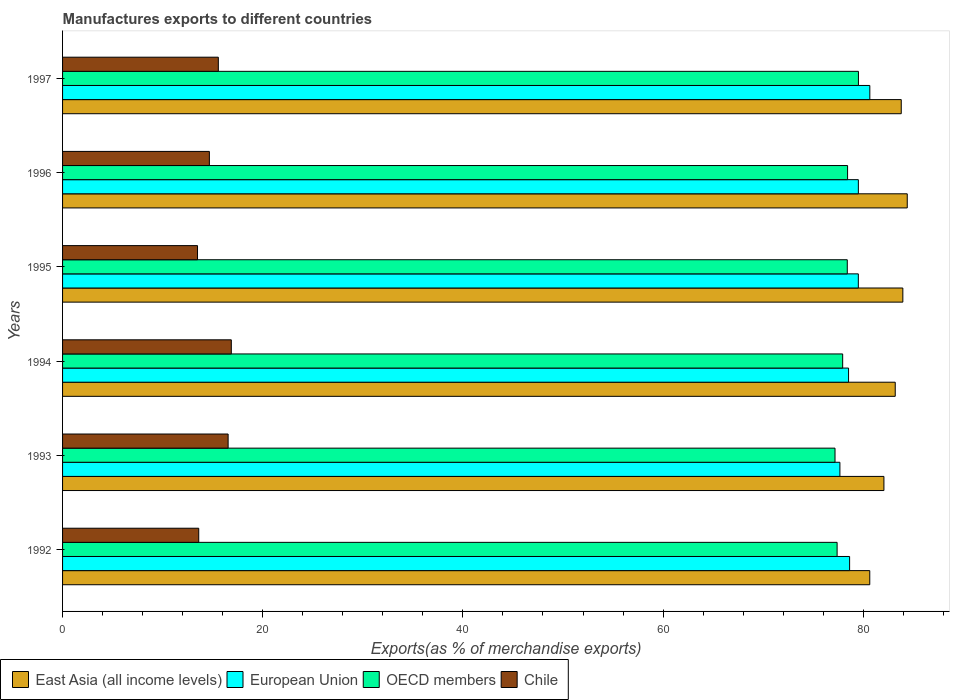How many different coloured bars are there?
Keep it short and to the point. 4. What is the label of the 1st group of bars from the top?
Provide a short and direct response. 1997. In how many cases, is the number of bars for a given year not equal to the number of legend labels?
Make the answer very short. 0. What is the percentage of exports to different countries in European Union in 1994?
Offer a very short reply. 78.53. Across all years, what is the maximum percentage of exports to different countries in Chile?
Your answer should be very brief. 16.86. Across all years, what is the minimum percentage of exports to different countries in OECD members?
Ensure brevity in your answer.  77.18. What is the total percentage of exports to different countries in OECD members in the graph?
Keep it short and to the point. 468.87. What is the difference between the percentage of exports to different countries in Chile in 1992 and that in 1994?
Make the answer very short. -3.25. What is the difference between the percentage of exports to different countries in OECD members in 1994 and the percentage of exports to different countries in East Asia (all income levels) in 1995?
Provide a short and direct response. -6.01. What is the average percentage of exports to different countries in East Asia (all income levels) per year?
Make the answer very short. 83.01. In the year 1994, what is the difference between the percentage of exports to different countries in OECD members and percentage of exports to different countries in European Union?
Make the answer very short. -0.59. In how many years, is the percentage of exports to different countries in Chile greater than 40 %?
Your answer should be compact. 0. What is the ratio of the percentage of exports to different countries in East Asia (all income levels) in 1993 to that in 1996?
Offer a very short reply. 0.97. Is the difference between the percentage of exports to different countries in OECD members in 1995 and 1997 greater than the difference between the percentage of exports to different countries in European Union in 1995 and 1997?
Keep it short and to the point. Yes. What is the difference between the highest and the second highest percentage of exports to different countries in European Union?
Give a very brief answer. 1.15. What is the difference between the highest and the lowest percentage of exports to different countries in OECD members?
Provide a short and direct response. 2.34. In how many years, is the percentage of exports to different countries in East Asia (all income levels) greater than the average percentage of exports to different countries in East Asia (all income levels) taken over all years?
Your response must be concise. 4. Is it the case that in every year, the sum of the percentage of exports to different countries in Chile and percentage of exports to different countries in OECD members is greater than the sum of percentage of exports to different countries in East Asia (all income levels) and percentage of exports to different countries in European Union?
Offer a terse response. No. What does the 4th bar from the top in 1993 represents?
Ensure brevity in your answer.  East Asia (all income levels). Are all the bars in the graph horizontal?
Ensure brevity in your answer.  Yes. How many years are there in the graph?
Offer a terse response. 6. How many legend labels are there?
Give a very brief answer. 4. What is the title of the graph?
Provide a succinct answer. Manufactures exports to different countries. What is the label or title of the X-axis?
Ensure brevity in your answer.  Exports(as % of merchandise exports). What is the label or title of the Y-axis?
Offer a terse response. Years. What is the Exports(as % of merchandise exports) in East Asia (all income levels) in 1992?
Provide a short and direct response. 80.65. What is the Exports(as % of merchandise exports) of European Union in 1992?
Provide a succinct answer. 78.64. What is the Exports(as % of merchandise exports) of OECD members in 1992?
Give a very brief answer. 77.39. What is the Exports(as % of merchandise exports) in Chile in 1992?
Offer a very short reply. 13.61. What is the Exports(as % of merchandise exports) in East Asia (all income levels) in 1993?
Provide a short and direct response. 82.07. What is the Exports(as % of merchandise exports) in European Union in 1993?
Ensure brevity in your answer.  77.67. What is the Exports(as % of merchandise exports) in OECD members in 1993?
Keep it short and to the point. 77.18. What is the Exports(as % of merchandise exports) of Chile in 1993?
Make the answer very short. 16.54. What is the Exports(as % of merchandise exports) in East Asia (all income levels) in 1994?
Your response must be concise. 83.2. What is the Exports(as % of merchandise exports) in European Union in 1994?
Make the answer very short. 78.53. What is the Exports(as % of merchandise exports) in OECD members in 1994?
Give a very brief answer. 77.94. What is the Exports(as % of merchandise exports) in Chile in 1994?
Your answer should be very brief. 16.86. What is the Exports(as % of merchandise exports) in East Asia (all income levels) in 1995?
Ensure brevity in your answer.  83.96. What is the Exports(as % of merchandise exports) in European Union in 1995?
Your answer should be compact. 79.51. What is the Exports(as % of merchandise exports) of OECD members in 1995?
Offer a terse response. 78.4. What is the Exports(as % of merchandise exports) in Chile in 1995?
Ensure brevity in your answer.  13.48. What is the Exports(as % of merchandise exports) of East Asia (all income levels) in 1996?
Your answer should be very brief. 84.4. What is the Exports(as % of merchandise exports) in European Union in 1996?
Make the answer very short. 79.51. What is the Exports(as % of merchandise exports) of OECD members in 1996?
Offer a very short reply. 78.43. What is the Exports(as % of merchandise exports) of Chile in 1996?
Your response must be concise. 14.67. What is the Exports(as % of merchandise exports) of East Asia (all income levels) in 1997?
Make the answer very short. 83.8. What is the Exports(as % of merchandise exports) in European Union in 1997?
Give a very brief answer. 80.66. What is the Exports(as % of merchandise exports) in OECD members in 1997?
Your response must be concise. 79.52. What is the Exports(as % of merchandise exports) in Chile in 1997?
Keep it short and to the point. 15.56. Across all years, what is the maximum Exports(as % of merchandise exports) in East Asia (all income levels)?
Give a very brief answer. 84.4. Across all years, what is the maximum Exports(as % of merchandise exports) of European Union?
Offer a terse response. 80.66. Across all years, what is the maximum Exports(as % of merchandise exports) of OECD members?
Keep it short and to the point. 79.52. Across all years, what is the maximum Exports(as % of merchandise exports) of Chile?
Give a very brief answer. 16.86. Across all years, what is the minimum Exports(as % of merchandise exports) in East Asia (all income levels)?
Your answer should be compact. 80.65. Across all years, what is the minimum Exports(as % of merchandise exports) of European Union?
Keep it short and to the point. 77.67. Across all years, what is the minimum Exports(as % of merchandise exports) of OECD members?
Your answer should be compact. 77.18. Across all years, what is the minimum Exports(as % of merchandise exports) of Chile?
Your answer should be very brief. 13.48. What is the total Exports(as % of merchandise exports) of East Asia (all income levels) in the graph?
Your answer should be very brief. 498.06. What is the total Exports(as % of merchandise exports) in European Union in the graph?
Your answer should be compact. 474.51. What is the total Exports(as % of merchandise exports) of OECD members in the graph?
Make the answer very short. 468.87. What is the total Exports(as % of merchandise exports) of Chile in the graph?
Ensure brevity in your answer.  90.72. What is the difference between the Exports(as % of merchandise exports) of East Asia (all income levels) in 1992 and that in 1993?
Give a very brief answer. -1.42. What is the difference between the Exports(as % of merchandise exports) of European Union in 1992 and that in 1993?
Give a very brief answer. 0.97. What is the difference between the Exports(as % of merchandise exports) of OECD members in 1992 and that in 1993?
Your answer should be very brief. 0.21. What is the difference between the Exports(as % of merchandise exports) in Chile in 1992 and that in 1993?
Ensure brevity in your answer.  -2.94. What is the difference between the Exports(as % of merchandise exports) in East Asia (all income levels) in 1992 and that in 1994?
Offer a very short reply. -2.55. What is the difference between the Exports(as % of merchandise exports) in European Union in 1992 and that in 1994?
Make the answer very short. 0.11. What is the difference between the Exports(as % of merchandise exports) of OECD members in 1992 and that in 1994?
Your response must be concise. -0.56. What is the difference between the Exports(as % of merchandise exports) in Chile in 1992 and that in 1994?
Your response must be concise. -3.25. What is the difference between the Exports(as % of merchandise exports) in East Asia (all income levels) in 1992 and that in 1995?
Your response must be concise. -3.31. What is the difference between the Exports(as % of merchandise exports) in European Union in 1992 and that in 1995?
Give a very brief answer. -0.87. What is the difference between the Exports(as % of merchandise exports) in OECD members in 1992 and that in 1995?
Make the answer very short. -1.02. What is the difference between the Exports(as % of merchandise exports) in Chile in 1992 and that in 1995?
Ensure brevity in your answer.  0.12. What is the difference between the Exports(as % of merchandise exports) in East Asia (all income levels) in 1992 and that in 1996?
Offer a terse response. -3.75. What is the difference between the Exports(as % of merchandise exports) in European Union in 1992 and that in 1996?
Provide a short and direct response. -0.87. What is the difference between the Exports(as % of merchandise exports) in OECD members in 1992 and that in 1996?
Your answer should be very brief. -1.04. What is the difference between the Exports(as % of merchandise exports) of Chile in 1992 and that in 1996?
Provide a short and direct response. -1.06. What is the difference between the Exports(as % of merchandise exports) in East Asia (all income levels) in 1992 and that in 1997?
Ensure brevity in your answer.  -3.15. What is the difference between the Exports(as % of merchandise exports) in European Union in 1992 and that in 1997?
Your answer should be very brief. -2.02. What is the difference between the Exports(as % of merchandise exports) of OECD members in 1992 and that in 1997?
Provide a succinct answer. -2.13. What is the difference between the Exports(as % of merchandise exports) in Chile in 1992 and that in 1997?
Ensure brevity in your answer.  -1.96. What is the difference between the Exports(as % of merchandise exports) of East Asia (all income levels) in 1993 and that in 1994?
Offer a very short reply. -1.13. What is the difference between the Exports(as % of merchandise exports) in European Union in 1993 and that in 1994?
Your answer should be very brief. -0.87. What is the difference between the Exports(as % of merchandise exports) in OECD members in 1993 and that in 1994?
Keep it short and to the point. -0.76. What is the difference between the Exports(as % of merchandise exports) in Chile in 1993 and that in 1994?
Provide a short and direct response. -0.32. What is the difference between the Exports(as % of merchandise exports) of East Asia (all income levels) in 1993 and that in 1995?
Offer a very short reply. -1.89. What is the difference between the Exports(as % of merchandise exports) of European Union in 1993 and that in 1995?
Give a very brief answer. -1.84. What is the difference between the Exports(as % of merchandise exports) of OECD members in 1993 and that in 1995?
Your response must be concise. -1.22. What is the difference between the Exports(as % of merchandise exports) of Chile in 1993 and that in 1995?
Your answer should be compact. 3.06. What is the difference between the Exports(as % of merchandise exports) of East Asia (all income levels) in 1993 and that in 1996?
Give a very brief answer. -2.33. What is the difference between the Exports(as % of merchandise exports) in European Union in 1993 and that in 1996?
Your answer should be very brief. -1.84. What is the difference between the Exports(as % of merchandise exports) of OECD members in 1993 and that in 1996?
Provide a short and direct response. -1.25. What is the difference between the Exports(as % of merchandise exports) of Chile in 1993 and that in 1996?
Your answer should be very brief. 1.87. What is the difference between the Exports(as % of merchandise exports) in East Asia (all income levels) in 1993 and that in 1997?
Your answer should be very brief. -1.73. What is the difference between the Exports(as % of merchandise exports) in European Union in 1993 and that in 1997?
Provide a short and direct response. -2.99. What is the difference between the Exports(as % of merchandise exports) in OECD members in 1993 and that in 1997?
Offer a very short reply. -2.34. What is the difference between the Exports(as % of merchandise exports) of Chile in 1993 and that in 1997?
Make the answer very short. 0.98. What is the difference between the Exports(as % of merchandise exports) of East Asia (all income levels) in 1994 and that in 1995?
Offer a terse response. -0.76. What is the difference between the Exports(as % of merchandise exports) of European Union in 1994 and that in 1995?
Make the answer very short. -0.98. What is the difference between the Exports(as % of merchandise exports) in OECD members in 1994 and that in 1995?
Your answer should be compact. -0.46. What is the difference between the Exports(as % of merchandise exports) in Chile in 1994 and that in 1995?
Make the answer very short. 3.38. What is the difference between the Exports(as % of merchandise exports) in East Asia (all income levels) in 1994 and that in 1996?
Provide a succinct answer. -1.2. What is the difference between the Exports(as % of merchandise exports) of European Union in 1994 and that in 1996?
Your response must be concise. -0.98. What is the difference between the Exports(as % of merchandise exports) in OECD members in 1994 and that in 1996?
Your response must be concise. -0.49. What is the difference between the Exports(as % of merchandise exports) of Chile in 1994 and that in 1996?
Ensure brevity in your answer.  2.19. What is the difference between the Exports(as % of merchandise exports) of East Asia (all income levels) in 1994 and that in 1997?
Give a very brief answer. -0.6. What is the difference between the Exports(as % of merchandise exports) in European Union in 1994 and that in 1997?
Provide a succinct answer. -2.12. What is the difference between the Exports(as % of merchandise exports) of OECD members in 1994 and that in 1997?
Your answer should be compact. -1.58. What is the difference between the Exports(as % of merchandise exports) in Chile in 1994 and that in 1997?
Provide a succinct answer. 1.3. What is the difference between the Exports(as % of merchandise exports) in East Asia (all income levels) in 1995 and that in 1996?
Keep it short and to the point. -0.44. What is the difference between the Exports(as % of merchandise exports) of European Union in 1995 and that in 1996?
Ensure brevity in your answer.  -0. What is the difference between the Exports(as % of merchandise exports) in OECD members in 1995 and that in 1996?
Give a very brief answer. -0.03. What is the difference between the Exports(as % of merchandise exports) of Chile in 1995 and that in 1996?
Your answer should be very brief. -1.19. What is the difference between the Exports(as % of merchandise exports) in East Asia (all income levels) in 1995 and that in 1997?
Provide a succinct answer. 0.16. What is the difference between the Exports(as % of merchandise exports) of European Union in 1995 and that in 1997?
Ensure brevity in your answer.  -1.15. What is the difference between the Exports(as % of merchandise exports) in OECD members in 1995 and that in 1997?
Your answer should be very brief. -1.12. What is the difference between the Exports(as % of merchandise exports) of Chile in 1995 and that in 1997?
Your answer should be compact. -2.08. What is the difference between the Exports(as % of merchandise exports) in East Asia (all income levels) in 1996 and that in 1997?
Keep it short and to the point. 0.6. What is the difference between the Exports(as % of merchandise exports) of European Union in 1996 and that in 1997?
Provide a short and direct response. -1.15. What is the difference between the Exports(as % of merchandise exports) of OECD members in 1996 and that in 1997?
Keep it short and to the point. -1.09. What is the difference between the Exports(as % of merchandise exports) in Chile in 1996 and that in 1997?
Keep it short and to the point. -0.89. What is the difference between the Exports(as % of merchandise exports) of East Asia (all income levels) in 1992 and the Exports(as % of merchandise exports) of European Union in 1993?
Your answer should be compact. 2.98. What is the difference between the Exports(as % of merchandise exports) of East Asia (all income levels) in 1992 and the Exports(as % of merchandise exports) of OECD members in 1993?
Offer a terse response. 3.47. What is the difference between the Exports(as % of merchandise exports) of East Asia (all income levels) in 1992 and the Exports(as % of merchandise exports) of Chile in 1993?
Give a very brief answer. 64.11. What is the difference between the Exports(as % of merchandise exports) of European Union in 1992 and the Exports(as % of merchandise exports) of OECD members in 1993?
Make the answer very short. 1.46. What is the difference between the Exports(as % of merchandise exports) of European Union in 1992 and the Exports(as % of merchandise exports) of Chile in 1993?
Your answer should be compact. 62.1. What is the difference between the Exports(as % of merchandise exports) of OECD members in 1992 and the Exports(as % of merchandise exports) of Chile in 1993?
Make the answer very short. 60.85. What is the difference between the Exports(as % of merchandise exports) of East Asia (all income levels) in 1992 and the Exports(as % of merchandise exports) of European Union in 1994?
Keep it short and to the point. 2.12. What is the difference between the Exports(as % of merchandise exports) of East Asia (all income levels) in 1992 and the Exports(as % of merchandise exports) of OECD members in 1994?
Ensure brevity in your answer.  2.71. What is the difference between the Exports(as % of merchandise exports) of East Asia (all income levels) in 1992 and the Exports(as % of merchandise exports) of Chile in 1994?
Your answer should be very brief. 63.79. What is the difference between the Exports(as % of merchandise exports) of European Union in 1992 and the Exports(as % of merchandise exports) of OECD members in 1994?
Keep it short and to the point. 0.69. What is the difference between the Exports(as % of merchandise exports) in European Union in 1992 and the Exports(as % of merchandise exports) in Chile in 1994?
Your answer should be compact. 61.78. What is the difference between the Exports(as % of merchandise exports) of OECD members in 1992 and the Exports(as % of merchandise exports) of Chile in 1994?
Your response must be concise. 60.53. What is the difference between the Exports(as % of merchandise exports) in East Asia (all income levels) in 1992 and the Exports(as % of merchandise exports) in European Union in 1995?
Make the answer very short. 1.14. What is the difference between the Exports(as % of merchandise exports) in East Asia (all income levels) in 1992 and the Exports(as % of merchandise exports) in OECD members in 1995?
Your answer should be very brief. 2.25. What is the difference between the Exports(as % of merchandise exports) in East Asia (all income levels) in 1992 and the Exports(as % of merchandise exports) in Chile in 1995?
Offer a terse response. 67.17. What is the difference between the Exports(as % of merchandise exports) in European Union in 1992 and the Exports(as % of merchandise exports) in OECD members in 1995?
Offer a terse response. 0.23. What is the difference between the Exports(as % of merchandise exports) of European Union in 1992 and the Exports(as % of merchandise exports) of Chile in 1995?
Provide a short and direct response. 65.15. What is the difference between the Exports(as % of merchandise exports) of OECD members in 1992 and the Exports(as % of merchandise exports) of Chile in 1995?
Keep it short and to the point. 63.91. What is the difference between the Exports(as % of merchandise exports) in East Asia (all income levels) in 1992 and the Exports(as % of merchandise exports) in European Union in 1996?
Your answer should be very brief. 1.14. What is the difference between the Exports(as % of merchandise exports) of East Asia (all income levels) in 1992 and the Exports(as % of merchandise exports) of OECD members in 1996?
Offer a terse response. 2.22. What is the difference between the Exports(as % of merchandise exports) in East Asia (all income levels) in 1992 and the Exports(as % of merchandise exports) in Chile in 1996?
Provide a short and direct response. 65.98. What is the difference between the Exports(as % of merchandise exports) of European Union in 1992 and the Exports(as % of merchandise exports) of OECD members in 1996?
Your response must be concise. 0.2. What is the difference between the Exports(as % of merchandise exports) in European Union in 1992 and the Exports(as % of merchandise exports) in Chile in 1996?
Provide a short and direct response. 63.97. What is the difference between the Exports(as % of merchandise exports) in OECD members in 1992 and the Exports(as % of merchandise exports) in Chile in 1996?
Ensure brevity in your answer.  62.72. What is the difference between the Exports(as % of merchandise exports) in East Asia (all income levels) in 1992 and the Exports(as % of merchandise exports) in European Union in 1997?
Give a very brief answer. -0.01. What is the difference between the Exports(as % of merchandise exports) in East Asia (all income levels) in 1992 and the Exports(as % of merchandise exports) in OECD members in 1997?
Keep it short and to the point. 1.13. What is the difference between the Exports(as % of merchandise exports) in East Asia (all income levels) in 1992 and the Exports(as % of merchandise exports) in Chile in 1997?
Provide a succinct answer. 65.09. What is the difference between the Exports(as % of merchandise exports) in European Union in 1992 and the Exports(as % of merchandise exports) in OECD members in 1997?
Your response must be concise. -0.88. What is the difference between the Exports(as % of merchandise exports) in European Union in 1992 and the Exports(as % of merchandise exports) in Chile in 1997?
Keep it short and to the point. 63.07. What is the difference between the Exports(as % of merchandise exports) in OECD members in 1992 and the Exports(as % of merchandise exports) in Chile in 1997?
Ensure brevity in your answer.  61.83. What is the difference between the Exports(as % of merchandise exports) in East Asia (all income levels) in 1993 and the Exports(as % of merchandise exports) in European Union in 1994?
Provide a short and direct response. 3.53. What is the difference between the Exports(as % of merchandise exports) in East Asia (all income levels) in 1993 and the Exports(as % of merchandise exports) in OECD members in 1994?
Your answer should be compact. 4.12. What is the difference between the Exports(as % of merchandise exports) in East Asia (all income levels) in 1993 and the Exports(as % of merchandise exports) in Chile in 1994?
Offer a very short reply. 65.21. What is the difference between the Exports(as % of merchandise exports) of European Union in 1993 and the Exports(as % of merchandise exports) of OECD members in 1994?
Offer a very short reply. -0.28. What is the difference between the Exports(as % of merchandise exports) of European Union in 1993 and the Exports(as % of merchandise exports) of Chile in 1994?
Provide a succinct answer. 60.81. What is the difference between the Exports(as % of merchandise exports) in OECD members in 1993 and the Exports(as % of merchandise exports) in Chile in 1994?
Make the answer very short. 60.32. What is the difference between the Exports(as % of merchandise exports) of East Asia (all income levels) in 1993 and the Exports(as % of merchandise exports) of European Union in 1995?
Provide a succinct answer. 2.56. What is the difference between the Exports(as % of merchandise exports) of East Asia (all income levels) in 1993 and the Exports(as % of merchandise exports) of OECD members in 1995?
Provide a short and direct response. 3.66. What is the difference between the Exports(as % of merchandise exports) of East Asia (all income levels) in 1993 and the Exports(as % of merchandise exports) of Chile in 1995?
Your answer should be compact. 68.58. What is the difference between the Exports(as % of merchandise exports) in European Union in 1993 and the Exports(as % of merchandise exports) in OECD members in 1995?
Provide a short and direct response. -0.74. What is the difference between the Exports(as % of merchandise exports) of European Union in 1993 and the Exports(as % of merchandise exports) of Chile in 1995?
Make the answer very short. 64.18. What is the difference between the Exports(as % of merchandise exports) of OECD members in 1993 and the Exports(as % of merchandise exports) of Chile in 1995?
Your response must be concise. 63.7. What is the difference between the Exports(as % of merchandise exports) in East Asia (all income levels) in 1993 and the Exports(as % of merchandise exports) in European Union in 1996?
Provide a succinct answer. 2.55. What is the difference between the Exports(as % of merchandise exports) in East Asia (all income levels) in 1993 and the Exports(as % of merchandise exports) in OECD members in 1996?
Make the answer very short. 3.63. What is the difference between the Exports(as % of merchandise exports) of East Asia (all income levels) in 1993 and the Exports(as % of merchandise exports) of Chile in 1996?
Offer a very short reply. 67.4. What is the difference between the Exports(as % of merchandise exports) of European Union in 1993 and the Exports(as % of merchandise exports) of OECD members in 1996?
Offer a terse response. -0.77. What is the difference between the Exports(as % of merchandise exports) in European Union in 1993 and the Exports(as % of merchandise exports) in Chile in 1996?
Give a very brief answer. 63. What is the difference between the Exports(as % of merchandise exports) in OECD members in 1993 and the Exports(as % of merchandise exports) in Chile in 1996?
Give a very brief answer. 62.51. What is the difference between the Exports(as % of merchandise exports) of East Asia (all income levels) in 1993 and the Exports(as % of merchandise exports) of European Union in 1997?
Offer a very short reply. 1.41. What is the difference between the Exports(as % of merchandise exports) in East Asia (all income levels) in 1993 and the Exports(as % of merchandise exports) in OECD members in 1997?
Make the answer very short. 2.55. What is the difference between the Exports(as % of merchandise exports) of East Asia (all income levels) in 1993 and the Exports(as % of merchandise exports) of Chile in 1997?
Offer a very short reply. 66.5. What is the difference between the Exports(as % of merchandise exports) of European Union in 1993 and the Exports(as % of merchandise exports) of OECD members in 1997?
Your response must be concise. -1.85. What is the difference between the Exports(as % of merchandise exports) in European Union in 1993 and the Exports(as % of merchandise exports) in Chile in 1997?
Offer a very short reply. 62.1. What is the difference between the Exports(as % of merchandise exports) in OECD members in 1993 and the Exports(as % of merchandise exports) in Chile in 1997?
Offer a very short reply. 61.62. What is the difference between the Exports(as % of merchandise exports) in East Asia (all income levels) in 1994 and the Exports(as % of merchandise exports) in European Union in 1995?
Give a very brief answer. 3.69. What is the difference between the Exports(as % of merchandise exports) of East Asia (all income levels) in 1994 and the Exports(as % of merchandise exports) of OECD members in 1995?
Make the answer very short. 4.79. What is the difference between the Exports(as % of merchandise exports) of East Asia (all income levels) in 1994 and the Exports(as % of merchandise exports) of Chile in 1995?
Your answer should be very brief. 69.71. What is the difference between the Exports(as % of merchandise exports) in European Union in 1994 and the Exports(as % of merchandise exports) in OECD members in 1995?
Offer a terse response. 0.13. What is the difference between the Exports(as % of merchandise exports) in European Union in 1994 and the Exports(as % of merchandise exports) in Chile in 1995?
Your response must be concise. 65.05. What is the difference between the Exports(as % of merchandise exports) of OECD members in 1994 and the Exports(as % of merchandise exports) of Chile in 1995?
Ensure brevity in your answer.  64.46. What is the difference between the Exports(as % of merchandise exports) in East Asia (all income levels) in 1994 and the Exports(as % of merchandise exports) in European Union in 1996?
Give a very brief answer. 3.68. What is the difference between the Exports(as % of merchandise exports) of East Asia (all income levels) in 1994 and the Exports(as % of merchandise exports) of OECD members in 1996?
Keep it short and to the point. 4.76. What is the difference between the Exports(as % of merchandise exports) in East Asia (all income levels) in 1994 and the Exports(as % of merchandise exports) in Chile in 1996?
Provide a short and direct response. 68.53. What is the difference between the Exports(as % of merchandise exports) of European Union in 1994 and the Exports(as % of merchandise exports) of OECD members in 1996?
Your response must be concise. 0.1. What is the difference between the Exports(as % of merchandise exports) of European Union in 1994 and the Exports(as % of merchandise exports) of Chile in 1996?
Your answer should be very brief. 63.86. What is the difference between the Exports(as % of merchandise exports) in OECD members in 1994 and the Exports(as % of merchandise exports) in Chile in 1996?
Make the answer very short. 63.28. What is the difference between the Exports(as % of merchandise exports) of East Asia (all income levels) in 1994 and the Exports(as % of merchandise exports) of European Union in 1997?
Ensure brevity in your answer.  2.54. What is the difference between the Exports(as % of merchandise exports) in East Asia (all income levels) in 1994 and the Exports(as % of merchandise exports) in OECD members in 1997?
Provide a succinct answer. 3.68. What is the difference between the Exports(as % of merchandise exports) in East Asia (all income levels) in 1994 and the Exports(as % of merchandise exports) in Chile in 1997?
Make the answer very short. 67.63. What is the difference between the Exports(as % of merchandise exports) of European Union in 1994 and the Exports(as % of merchandise exports) of OECD members in 1997?
Give a very brief answer. -0.99. What is the difference between the Exports(as % of merchandise exports) in European Union in 1994 and the Exports(as % of merchandise exports) in Chile in 1997?
Offer a very short reply. 62.97. What is the difference between the Exports(as % of merchandise exports) in OECD members in 1994 and the Exports(as % of merchandise exports) in Chile in 1997?
Offer a terse response. 62.38. What is the difference between the Exports(as % of merchandise exports) in East Asia (all income levels) in 1995 and the Exports(as % of merchandise exports) in European Union in 1996?
Give a very brief answer. 4.44. What is the difference between the Exports(as % of merchandise exports) in East Asia (all income levels) in 1995 and the Exports(as % of merchandise exports) in OECD members in 1996?
Provide a succinct answer. 5.52. What is the difference between the Exports(as % of merchandise exports) in East Asia (all income levels) in 1995 and the Exports(as % of merchandise exports) in Chile in 1996?
Keep it short and to the point. 69.29. What is the difference between the Exports(as % of merchandise exports) of European Union in 1995 and the Exports(as % of merchandise exports) of OECD members in 1996?
Offer a very short reply. 1.08. What is the difference between the Exports(as % of merchandise exports) of European Union in 1995 and the Exports(as % of merchandise exports) of Chile in 1996?
Offer a terse response. 64.84. What is the difference between the Exports(as % of merchandise exports) in OECD members in 1995 and the Exports(as % of merchandise exports) in Chile in 1996?
Make the answer very short. 63.74. What is the difference between the Exports(as % of merchandise exports) of East Asia (all income levels) in 1995 and the Exports(as % of merchandise exports) of European Union in 1997?
Your response must be concise. 3.3. What is the difference between the Exports(as % of merchandise exports) in East Asia (all income levels) in 1995 and the Exports(as % of merchandise exports) in OECD members in 1997?
Provide a succinct answer. 4.44. What is the difference between the Exports(as % of merchandise exports) in East Asia (all income levels) in 1995 and the Exports(as % of merchandise exports) in Chile in 1997?
Provide a succinct answer. 68.39. What is the difference between the Exports(as % of merchandise exports) in European Union in 1995 and the Exports(as % of merchandise exports) in OECD members in 1997?
Offer a terse response. -0.01. What is the difference between the Exports(as % of merchandise exports) of European Union in 1995 and the Exports(as % of merchandise exports) of Chile in 1997?
Make the answer very short. 63.95. What is the difference between the Exports(as % of merchandise exports) in OECD members in 1995 and the Exports(as % of merchandise exports) in Chile in 1997?
Give a very brief answer. 62.84. What is the difference between the Exports(as % of merchandise exports) of East Asia (all income levels) in 1996 and the Exports(as % of merchandise exports) of European Union in 1997?
Keep it short and to the point. 3.74. What is the difference between the Exports(as % of merchandise exports) in East Asia (all income levels) in 1996 and the Exports(as % of merchandise exports) in OECD members in 1997?
Keep it short and to the point. 4.88. What is the difference between the Exports(as % of merchandise exports) in East Asia (all income levels) in 1996 and the Exports(as % of merchandise exports) in Chile in 1997?
Give a very brief answer. 68.83. What is the difference between the Exports(as % of merchandise exports) of European Union in 1996 and the Exports(as % of merchandise exports) of OECD members in 1997?
Make the answer very short. -0.01. What is the difference between the Exports(as % of merchandise exports) in European Union in 1996 and the Exports(as % of merchandise exports) in Chile in 1997?
Make the answer very short. 63.95. What is the difference between the Exports(as % of merchandise exports) in OECD members in 1996 and the Exports(as % of merchandise exports) in Chile in 1997?
Keep it short and to the point. 62.87. What is the average Exports(as % of merchandise exports) of East Asia (all income levels) per year?
Offer a terse response. 83.01. What is the average Exports(as % of merchandise exports) in European Union per year?
Provide a short and direct response. 79.09. What is the average Exports(as % of merchandise exports) in OECD members per year?
Keep it short and to the point. 78.14. What is the average Exports(as % of merchandise exports) in Chile per year?
Provide a short and direct response. 15.12. In the year 1992, what is the difference between the Exports(as % of merchandise exports) of East Asia (all income levels) and Exports(as % of merchandise exports) of European Union?
Your answer should be very brief. 2.01. In the year 1992, what is the difference between the Exports(as % of merchandise exports) in East Asia (all income levels) and Exports(as % of merchandise exports) in OECD members?
Provide a succinct answer. 3.26. In the year 1992, what is the difference between the Exports(as % of merchandise exports) of East Asia (all income levels) and Exports(as % of merchandise exports) of Chile?
Your answer should be compact. 67.04. In the year 1992, what is the difference between the Exports(as % of merchandise exports) in European Union and Exports(as % of merchandise exports) in OECD members?
Your answer should be very brief. 1.25. In the year 1992, what is the difference between the Exports(as % of merchandise exports) in European Union and Exports(as % of merchandise exports) in Chile?
Your answer should be very brief. 65.03. In the year 1992, what is the difference between the Exports(as % of merchandise exports) in OECD members and Exports(as % of merchandise exports) in Chile?
Ensure brevity in your answer.  63.78. In the year 1993, what is the difference between the Exports(as % of merchandise exports) in East Asia (all income levels) and Exports(as % of merchandise exports) in European Union?
Keep it short and to the point. 4.4. In the year 1993, what is the difference between the Exports(as % of merchandise exports) of East Asia (all income levels) and Exports(as % of merchandise exports) of OECD members?
Offer a terse response. 4.89. In the year 1993, what is the difference between the Exports(as % of merchandise exports) in East Asia (all income levels) and Exports(as % of merchandise exports) in Chile?
Make the answer very short. 65.52. In the year 1993, what is the difference between the Exports(as % of merchandise exports) of European Union and Exports(as % of merchandise exports) of OECD members?
Your answer should be compact. 0.49. In the year 1993, what is the difference between the Exports(as % of merchandise exports) in European Union and Exports(as % of merchandise exports) in Chile?
Make the answer very short. 61.12. In the year 1993, what is the difference between the Exports(as % of merchandise exports) of OECD members and Exports(as % of merchandise exports) of Chile?
Your answer should be compact. 60.64. In the year 1994, what is the difference between the Exports(as % of merchandise exports) of East Asia (all income levels) and Exports(as % of merchandise exports) of European Union?
Your response must be concise. 4.66. In the year 1994, what is the difference between the Exports(as % of merchandise exports) in East Asia (all income levels) and Exports(as % of merchandise exports) in OECD members?
Keep it short and to the point. 5.25. In the year 1994, what is the difference between the Exports(as % of merchandise exports) of East Asia (all income levels) and Exports(as % of merchandise exports) of Chile?
Provide a short and direct response. 66.34. In the year 1994, what is the difference between the Exports(as % of merchandise exports) of European Union and Exports(as % of merchandise exports) of OECD members?
Your answer should be very brief. 0.59. In the year 1994, what is the difference between the Exports(as % of merchandise exports) in European Union and Exports(as % of merchandise exports) in Chile?
Offer a terse response. 61.67. In the year 1994, what is the difference between the Exports(as % of merchandise exports) in OECD members and Exports(as % of merchandise exports) in Chile?
Your answer should be compact. 61.08. In the year 1995, what is the difference between the Exports(as % of merchandise exports) in East Asia (all income levels) and Exports(as % of merchandise exports) in European Union?
Provide a short and direct response. 4.45. In the year 1995, what is the difference between the Exports(as % of merchandise exports) of East Asia (all income levels) and Exports(as % of merchandise exports) of OECD members?
Offer a very short reply. 5.55. In the year 1995, what is the difference between the Exports(as % of merchandise exports) of East Asia (all income levels) and Exports(as % of merchandise exports) of Chile?
Keep it short and to the point. 70.47. In the year 1995, what is the difference between the Exports(as % of merchandise exports) of European Union and Exports(as % of merchandise exports) of OECD members?
Keep it short and to the point. 1.1. In the year 1995, what is the difference between the Exports(as % of merchandise exports) in European Union and Exports(as % of merchandise exports) in Chile?
Offer a very short reply. 66.03. In the year 1995, what is the difference between the Exports(as % of merchandise exports) in OECD members and Exports(as % of merchandise exports) in Chile?
Offer a very short reply. 64.92. In the year 1996, what is the difference between the Exports(as % of merchandise exports) of East Asia (all income levels) and Exports(as % of merchandise exports) of European Union?
Provide a succinct answer. 4.89. In the year 1996, what is the difference between the Exports(as % of merchandise exports) of East Asia (all income levels) and Exports(as % of merchandise exports) of OECD members?
Provide a short and direct response. 5.96. In the year 1996, what is the difference between the Exports(as % of merchandise exports) of East Asia (all income levels) and Exports(as % of merchandise exports) of Chile?
Give a very brief answer. 69.73. In the year 1996, what is the difference between the Exports(as % of merchandise exports) in European Union and Exports(as % of merchandise exports) in OECD members?
Your answer should be very brief. 1.08. In the year 1996, what is the difference between the Exports(as % of merchandise exports) of European Union and Exports(as % of merchandise exports) of Chile?
Offer a terse response. 64.84. In the year 1996, what is the difference between the Exports(as % of merchandise exports) in OECD members and Exports(as % of merchandise exports) in Chile?
Keep it short and to the point. 63.77. In the year 1997, what is the difference between the Exports(as % of merchandise exports) in East Asia (all income levels) and Exports(as % of merchandise exports) in European Union?
Give a very brief answer. 3.14. In the year 1997, what is the difference between the Exports(as % of merchandise exports) in East Asia (all income levels) and Exports(as % of merchandise exports) in OECD members?
Make the answer very short. 4.28. In the year 1997, what is the difference between the Exports(as % of merchandise exports) in East Asia (all income levels) and Exports(as % of merchandise exports) in Chile?
Offer a very short reply. 68.23. In the year 1997, what is the difference between the Exports(as % of merchandise exports) of European Union and Exports(as % of merchandise exports) of OECD members?
Provide a short and direct response. 1.14. In the year 1997, what is the difference between the Exports(as % of merchandise exports) in European Union and Exports(as % of merchandise exports) in Chile?
Keep it short and to the point. 65.09. In the year 1997, what is the difference between the Exports(as % of merchandise exports) in OECD members and Exports(as % of merchandise exports) in Chile?
Make the answer very short. 63.96. What is the ratio of the Exports(as % of merchandise exports) of East Asia (all income levels) in 1992 to that in 1993?
Your answer should be compact. 0.98. What is the ratio of the Exports(as % of merchandise exports) of European Union in 1992 to that in 1993?
Your response must be concise. 1.01. What is the ratio of the Exports(as % of merchandise exports) of OECD members in 1992 to that in 1993?
Ensure brevity in your answer.  1. What is the ratio of the Exports(as % of merchandise exports) of Chile in 1992 to that in 1993?
Offer a very short reply. 0.82. What is the ratio of the Exports(as % of merchandise exports) in East Asia (all income levels) in 1992 to that in 1994?
Provide a succinct answer. 0.97. What is the ratio of the Exports(as % of merchandise exports) in European Union in 1992 to that in 1994?
Give a very brief answer. 1. What is the ratio of the Exports(as % of merchandise exports) in OECD members in 1992 to that in 1994?
Make the answer very short. 0.99. What is the ratio of the Exports(as % of merchandise exports) in Chile in 1992 to that in 1994?
Provide a short and direct response. 0.81. What is the ratio of the Exports(as % of merchandise exports) in East Asia (all income levels) in 1992 to that in 1995?
Give a very brief answer. 0.96. What is the ratio of the Exports(as % of merchandise exports) in European Union in 1992 to that in 1995?
Provide a succinct answer. 0.99. What is the ratio of the Exports(as % of merchandise exports) in OECD members in 1992 to that in 1995?
Offer a terse response. 0.99. What is the ratio of the Exports(as % of merchandise exports) of Chile in 1992 to that in 1995?
Your answer should be compact. 1.01. What is the ratio of the Exports(as % of merchandise exports) in East Asia (all income levels) in 1992 to that in 1996?
Make the answer very short. 0.96. What is the ratio of the Exports(as % of merchandise exports) of European Union in 1992 to that in 1996?
Ensure brevity in your answer.  0.99. What is the ratio of the Exports(as % of merchandise exports) of OECD members in 1992 to that in 1996?
Offer a very short reply. 0.99. What is the ratio of the Exports(as % of merchandise exports) in Chile in 1992 to that in 1996?
Offer a terse response. 0.93. What is the ratio of the Exports(as % of merchandise exports) in East Asia (all income levels) in 1992 to that in 1997?
Ensure brevity in your answer.  0.96. What is the ratio of the Exports(as % of merchandise exports) in OECD members in 1992 to that in 1997?
Keep it short and to the point. 0.97. What is the ratio of the Exports(as % of merchandise exports) in Chile in 1992 to that in 1997?
Provide a succinct answer. 0.87. What is the ratio of the Exports(as % of merchandise exports) in East Asia (all income levels) in 1993 to that in 1994?
Your response must be concise. 0.99. What is the ratio of the Exports(as % of merchandise exports) in European Union in 1993 to that in 1994?
Provide a short and direct response. 0.99. What is the ratio of the Exports(as % of merchandise exports) of OECD members in 1993 to that in 1994?
Keep it short and to the point. 0.99. What is the ratio of the Exports(as % of merchandise exports) in Chile in 1993 to that in 1994?
Your answer should be compact. 0.98. What is the ratio of the Exports(as % of merchandise exports) in East Asia (all income levels) in 1993 to that in 1995?
Your response must be concise. 0.98. What is the ratio of the Exports(as % of merchandise exports) in European Union in 1993 to that in 1995?
Your answer should be compact. 0.98. What is the ratio of the Exports(as % of merchandise exports) of OECD members in 1993 to that in 1995?
Your answer should be compact. 0.98. What is the ratio of the Exports(as % of merchandise exports) of Chile in 1993 to that in 1995?
Your answer should be compact. 1.23. What is the ratio of the Exports(as % of merchandise exports) of East Asia (all income levels) in 1993 to that in 1996?
Give a very brief answer. 0.97. What is the ratio of the Exports(as % of merchandise exports) in European Union in 1993 to that in 1996?
Make the answer very short. 0.98. What is the ratio of the Exports(as % of merchandise exports) in OECD members in 1993 to that in 1996?
Your answer should be very brief. 0.98. What is the ratio of the Exports(as % of merchandise exports) in Chile in 1993 to that in 1996?
Offer a terse response. 1.13. What is the ratio of the Exports(as % of merchandise exports) in East Asia (all income levels) in 1993 to that in 1997?
Give a very brief answer. 0.98. What is the ratio of the Exports(as % of merchandise exports) of European Union in 1993 to that in 1997?
Offer a terse response. 0.96. What is the ratio of the Exports(as % of merchandise exports) of OECD members in 1993 to that in 1997?
Your answer should be very brief. 0.97. What is the ratio of the Exports(as % of merchandise exports) of Chile in 1993 to that in 1997?
Your answer should be very brief. 1.06. What is the ratio of the Exports(as % of merchandise exports) of European Union in 1994 to that in 1995?
Provide a succinct answer. 0.99. What is the ratio of the Exports(as % of merchandise exports) of Chile in 1994 to that in 1995?
Keep it short and to the point. 1.25. What is the ratio of the Exports(as % of merchandise exports) in East Asia (all income levels) in 1994 to that in 1996?
Your answer should be very brief. 0.99. What is the ratio of the Exports(as % of merchandise exports) in European Union in 1994 to that in 1996?
Provide a short and direct response. 0.99. What is the ratio of the Exports(as % of merchandise exports) of OECD members in 1994 to that in 1996?
Give a very brief answer. 0.99. What is the ratio of the Exports(as % of merchandise exports) in Chile in 1994 to that in 1996?
Your answer should be very brief. 1.15. What is the ratio of the Exports(as % of merchandise exports) of European Union in 1994 to that in 1997?
Keep it short and to the point. 0.97. What is the ratio of the Exports(as % of merchandise exports) in OECD members in 1994 to that in 1997?
Keep it short and to the point. 0.98. What is the ratio of the Exports(as % of merchandise exports) in Chile in 1994 to that in 1997?
Provide a succinct answer. 1.08. What is the ratio of the Exports(as % of merchandise exports) in Chile in 1995 to that in 1996?
Give a very brief answer. 0.92. What is the ratio of the Exports(as % of merchandise exports) of European Union in 1995 to that in 1997?
Offer a terse response. 0.99. What is the ratio of the Exports(as % of merchandise exports) in OECD members in 1995 to that in 1997?
Provide a short and direct response. 0.99. What is the ratio of the Exports(as % of merchandise exports) in Chile in 1995 to that in 1997?
Your answer should be very brief. 0.87. What is the ratio of the Exports(as % of merchandise exports) of European Union in 1996 to that in 1997?
Offer a very short reply. 0.99. What is the ratio of the Exports(as % of merchandise exports) in OECD members in 1996 to that in 1997?
Make the answer very short. 0.99. What is the ratio of the Exports(as % of merchandise exports) of Chile in 1996 to that in 1997?
Give a very brief answer. 0.94. What is the difference between the highest and the second highest Exports(as % of merchandise exports) in East Asia (all income levels)?
Your answer should be compact. 0.44. What is the difference between the highest and the second highest Exports(as % of merchandise exports) of European Union?
Your answer should be compact. 1.15. What is the difference between the highest and the second highest Exports(as % of merchandise exports) in OECD members?
Offer a very short reply. 1.09. What is the difference between the highest and the second highest Exports(as % of merchandise exports) of Chile?
Ensure brevity in your answer.  0.32. What is the difference between the highest and the lowest Exports(as % of merchandise exports) in East Asia (all income levels)?
Provide a short and direct response. 3.75. What is the difference between the highest and the lowest Exports(as % of merchandise exports) of European Union?
Make the answer very short. 2.99. What is the difference between the highest and the lowest Exports(as % of merchandise exports) of OECD members?
Make the answer very short. 2.34. What is the difference between the highest and the lowest Exports(as % of merchandise exports) of Chile?
Offer a terse response. 3.38. 